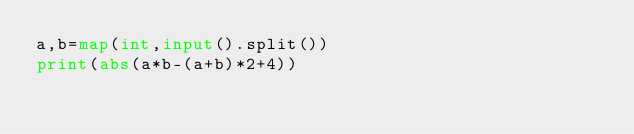Convert code to text. <code><loc_0><loc_0><loc_500><loc_500><_Python_>a,b=map(int,input().split())
print(abs(a*b-(a+b)*2+4))</code> 